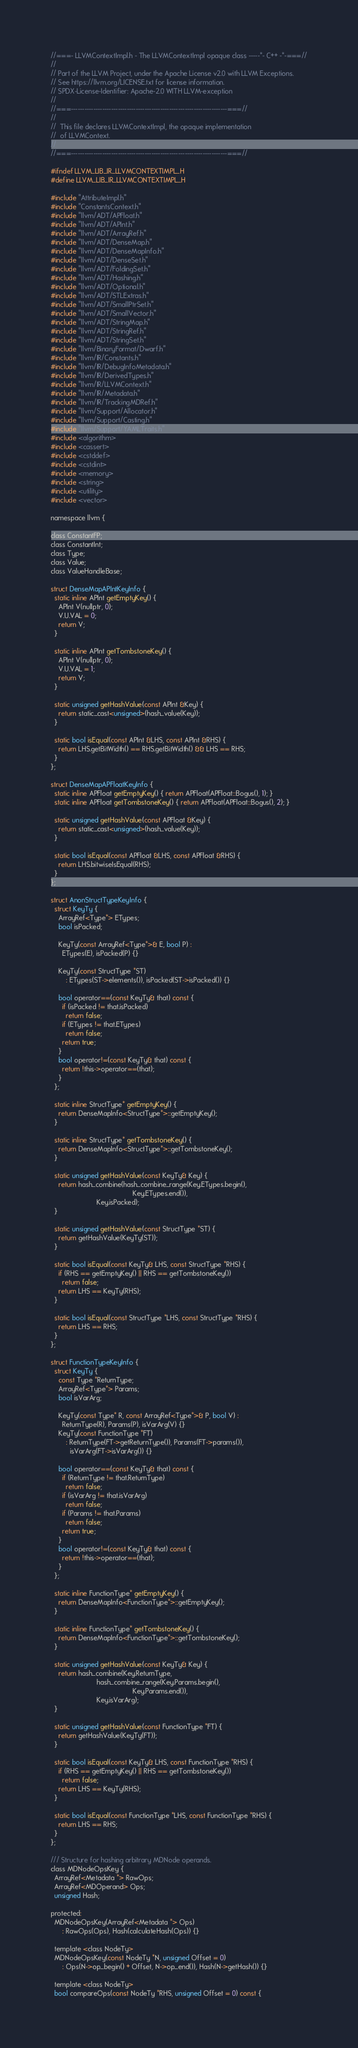<code> <loc_0><loc_0><loc_500><loc_500><_C_>//===- LLVMContextImpl.h - The LLVMContextImpl opaque class -----*- C++ -*-===//
//
// Part of the LLVM Project, under the Apache License v2.0 with LLVM Exceptions.
// See https://llvm.org/LICENSE.txt for license information.
// SPDX-License-Identifier: Apache-2.0 WITH LLVM-exception
//
//===----------------------------------------------------------------------===//
//
//  This file declares LLVMContextImpl, the opaque implementation
//  of LLVMContext.
//
//===----------------------------------------------------------------------===//

#ifndef LLVM_LIB_IR_LLVMCONTEXTIMPL_H
#define LLVM_LIB_IR_LLVMCONTEXTIMPL_H

#include "AttributeImpl.h"
#include "ConstantsContext.h"
#include "llvm/ADT/APFloat.h"
#include "llvm/ADT/APInt.h"
#include "llvm/ADT/ArrayRef.h"
#include "llvm/ADT/DenseMap.h"
#include "llvm/ADT/DenseMapInfo.h"
#include "llvm/ADT/DenseSet.h"
#include "llvm/ADT/FoldingSet.h"
#include "llvm/ADT/Hashing.h"
#include "llvm/ADT/Optional.h"
#include "llvm/ADT/STLExtras.h"
#include "llvm/ADT/SmallPtrSet.h"
#include "llvm/ADT/SmallVector.h"
#include "llvm/ADT/StringMap.h"
#include "llvm/ADT/StringRef.h"
#include "llvm/ADT/StringSet.h"
#include "llvm/BinaryFormat/Dwarf.h"
#include "llvm/IR/Constants.h"
#include "llvm/IR/DebugInfoMetadata.h"
#include "llvm/IR/DerivedTypes.h"
#include "llvm/IR/LLVMContext.h"
#include "llvm/IR/Metadata.h"
#include "llvm/IR/TrackingMDRef.h"
#include "llvm/Support/Allocator.h"
#include "llvm/Support/Casting.h"
#include "llvm/Support/YAMLTraits.h"
#include <algorithm>
#include <cassert>
#include <cstddef>
#include <cstdint>
#include <memory>
#include <string>
#include <utility>
#include <vector>

namespace llvm {

class ConstantFP;
class ConstantInt;
class Type;
class Value;
class ValueHandleBase;

struct DenseMapAPIntKeyInfo {
  static inline APInt getEmptyKey() {
    APInt V(nullptr, 0);
    V.U.VAL = 0;
    return V;
  }

  static inline APInt getTombstoneKey() {
    APInt V(nullptr, 0);
    V.U.VAL = 1;
    return V;
  }

  static unsigned getHashValue(const APInt &Key) {
    return static_cast<unsigned>(hash_value(Key));
  }

  static bool isEqual(const APInt &LHS, const APInt &RHS) {
    return LHS.getBitWidth() == RHS.getBitWidth() && LHS == RHS;
  }
};

struct DenseMapAPFloatKeyInfo {
  static inline APFloat getEmptyKey() { return APFloat(APFloat::Bogus(), 1); }
  static inline APFloat getTombstoneKey() { return APFloat(APFloat::Bogus(), 2); }

  static unsigned getHashValue(const APFloat &Key) {
    return static_cast<unsigned>(hash_value(Key));
  }

  static bool isEqual(const APFloat &LHS, const APFloat &RHS) {
    return LHS.bitwiseIsEqual(RHS);
  }
};

struct AnonStructTypeKeyInfo {
  struct KeyTy {
    ArrayRef<Type*> ETypes;
    bool isPacked;

    KeyTy(const ArrayRef<Type*>& E, bool P) :
      ETypes(E), isPacked(P) {}

    KeyTy(const StructType *ST)
        : ETypes(ST->elements()), isPacked(ST->isPacked()) {}

    bool operator==(const KeyTy& that) const {
      if (isPacked != that.isPacked)
        return false;
      if (ETypes != that.ETypes)
        return false;
      return true;
    }
    bool operator!=(const KeyTy& that) const {
      return !this->operator==(that);
    }
  };

  static inline StructType* getEmptyKey() {
    return DenseMapInfo<StructType*>::getEmptyKey();
  }

  static inline StructType* getTombstoneKey() {
    return DenseMapInfo<StructType*>::getTombstoneKey();
  }

  static unsigned getHashValue(const KeyTy& Key) {
    return hash_combine(hash_combine_range(Key.ETypes.begin(),
                                           Key.ETypes.end()),
                        Key.isPacked);
  }

  static unsigned getHashValue(const StructType *ST) {
    return getHashValue(KeyTy(ST));
  }

  static bool isEqual(const KeyTy& LHS, const StructType *RHS) {
    if (RHS == getEmptyKey() || RHS == getTombstoneKey())
      return false;
    return LHS == KeyTy(RHS);
  }

  static bool isEqual(const StructType *LHS, const StructType *RHS) {
    return LHS == RHS;
  }
};

struct FunctionTypeKeyInfo {
  struct KeyTy {
    const Type *ReturnType;
    ArrayRef<Type*> Params;
    bool isVarArg;

    KeyTy(const Type* R, const ArrayRef<Type*>& P, bool V) :
      ReturnType(R), Params(P), isVarArg(V) {}
    KeyTy(const FunctionType *FT)
        : ReturnType(FT->getReturnType()), Params(FT->params()),
          isVarArg(FT->isVarArg()) {}

    bool operator==(const KeyTy& that) const {
      if (ReturnType != that.ReturnType)
        return false;
      if (isVarArg != that.isVarArg)
        return false;
      if (Params != that.Params)
        return false;
      return true;
    }
    bool operator!=(const KeyTy& that) const {
      return !this->operator==(that);
    }
  };

  static inline FunctionType* getEmptyKey() {
    return DenseMapInfo<FunctionType*>::getEmptyKey();
  }

  static inline FunctionType* getTombstoneKey() {
    return DenseMapInfo<FunctionType*>::getTombstoneKey();
  }

  static unsigned getHashValue(const KeyTy& Key) {
    return hash_combine(Key.ReturnType,
                        hash_combine_range(Key.Params.begin(),
                                           Key.Params.end()),
                        Key.isVarArg);
  }

  static unsigned getHashValue(const FunctionType *FT) {
    return getHashValue(KeyTy(FT));
  }

  static bool isEqual(const KeyTy& LHS, const FunctionType *RHS) {
    if (RHS == getEmptyKey() || RHS == getTombstoneKey())
      return false;
    return LHS == KeyTy(RHS);
  }

  static bool isEqual(const FunctionType *LHS, const FunctionType *RHS) {
    return LHS == RHS;
  }
};

/// Structure for hashing arbitrary MDNode operands.
class MDNodeOpsKey {
  ArrayRef<Metadata *> RawOps;
  ArrayRef<MDOperand> Ops;
  unsigned Hash;

protected:
  MDNodeOpsKey(ArrayRef<Metadata *> Ops)
      : RawOps(Ops), Hash(calculateHash(Ops)) {}

  template <class NodeTy>
  MDNodeOpsKey(const NodeTy *N, unsigned Offset = 0)
      : Ops(N->op_begin() + Offset, N->op_end()), Hash(N->getHash()) {}

  template <class NodeTy>
  bool compareOps(const NodeTy *RHS, unsigned Offset = 0) const {</code> 